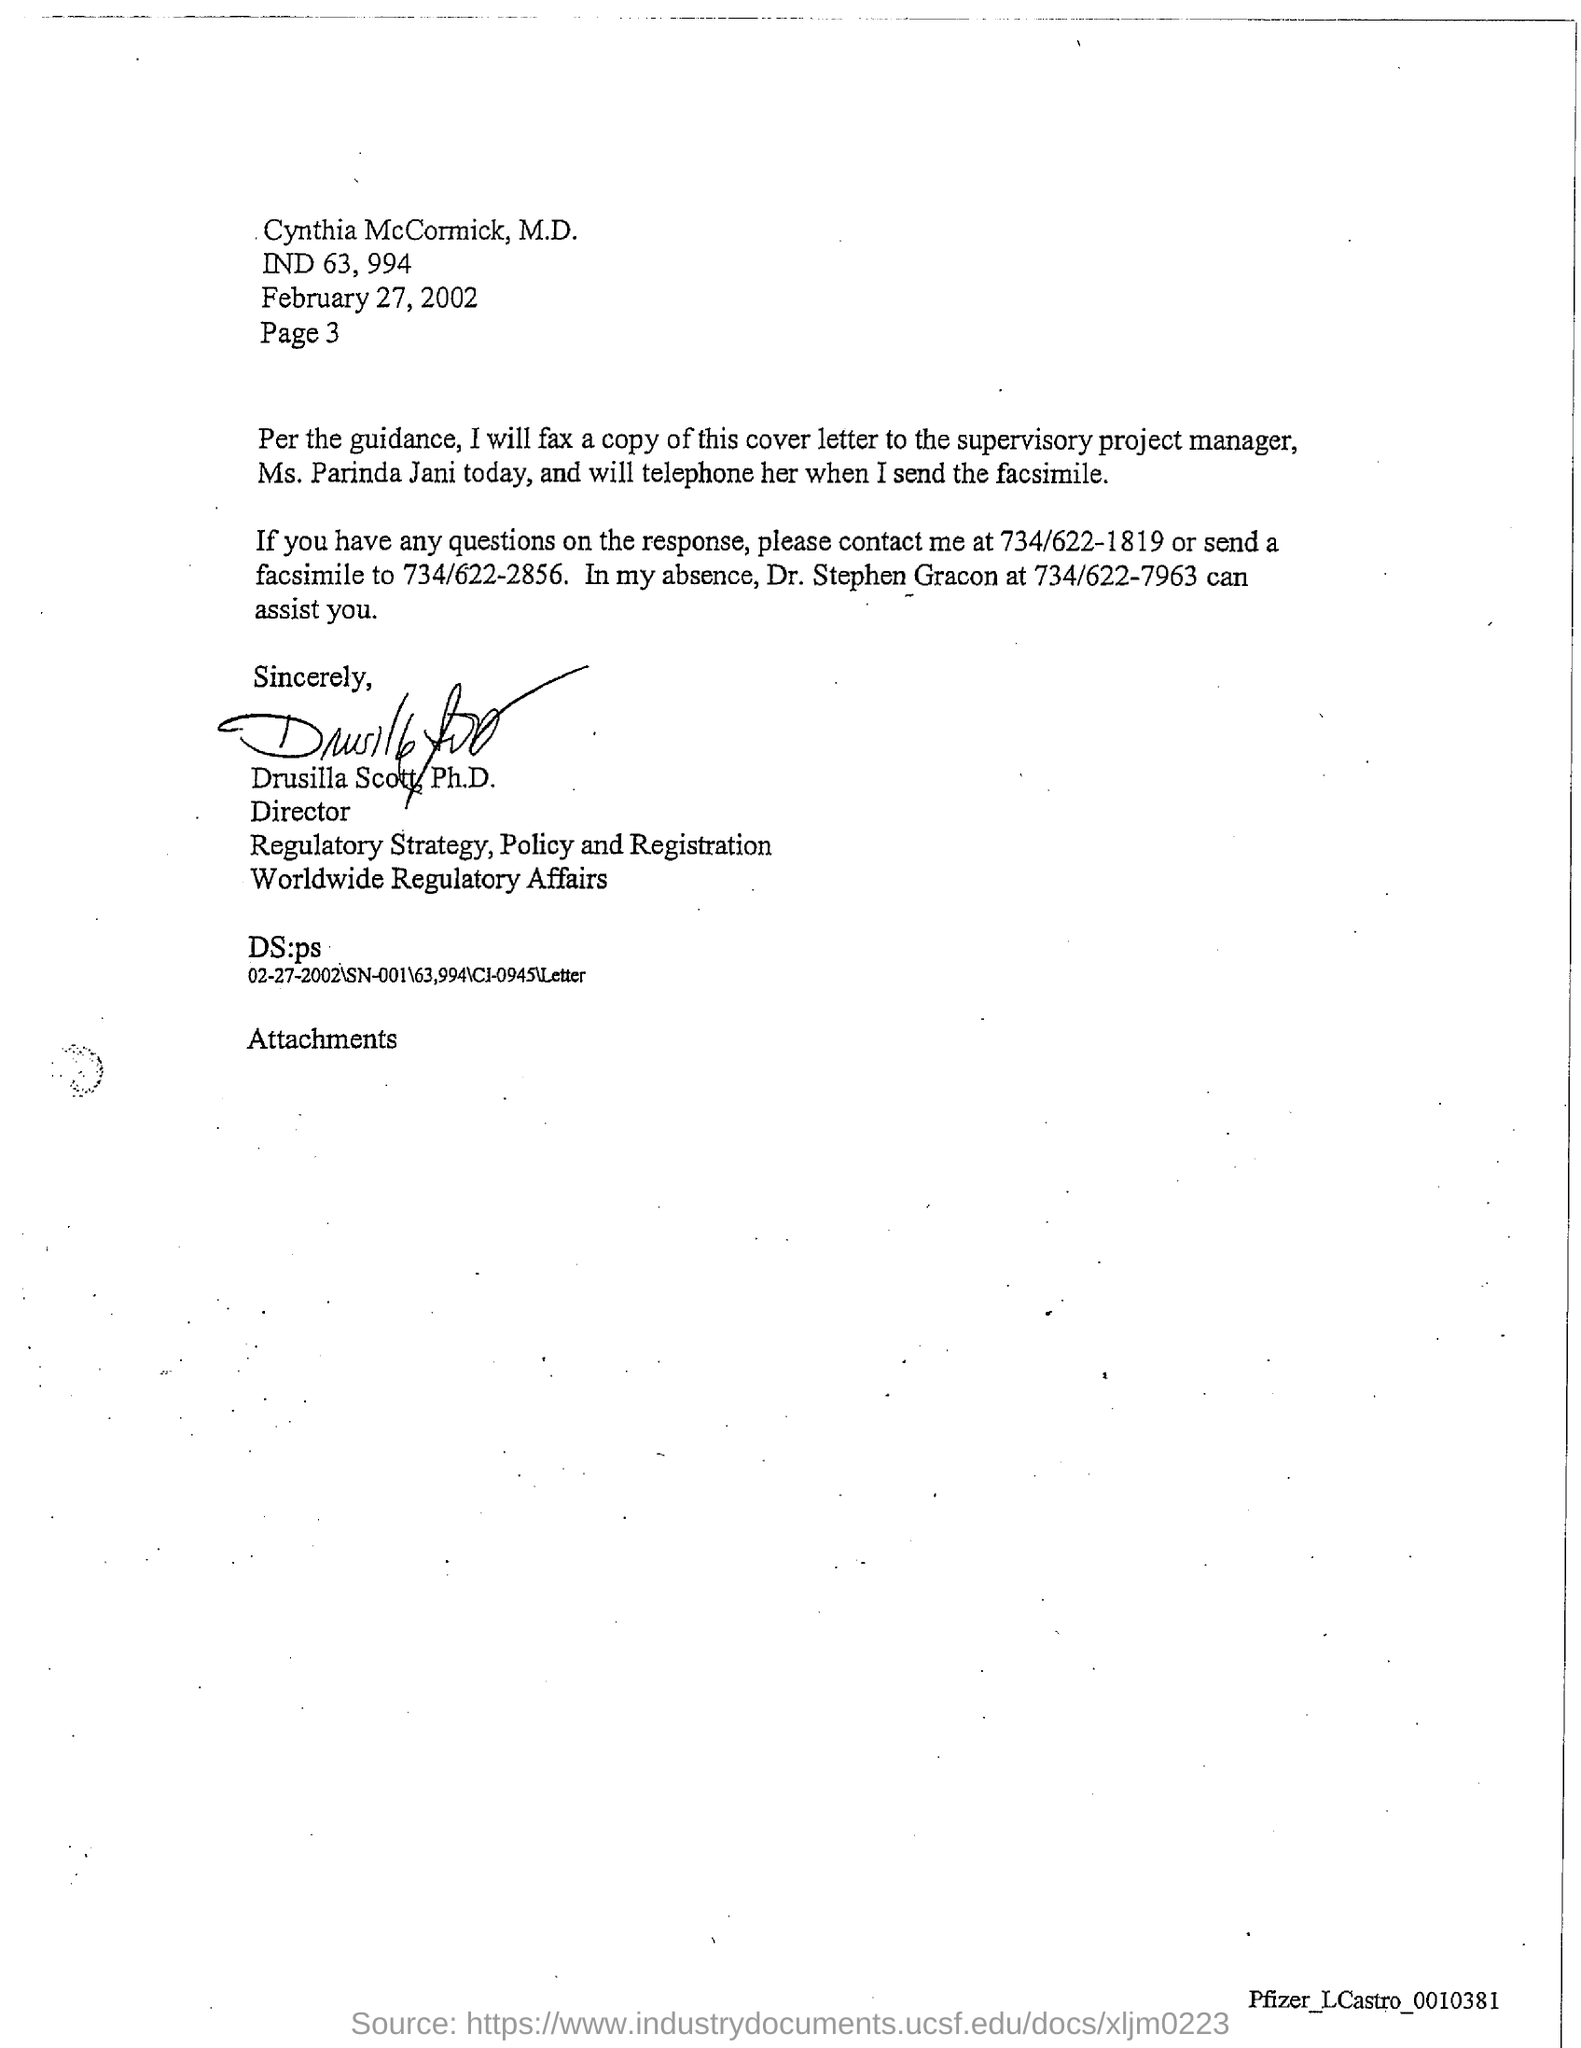Specify some key components in this picture. The letter has been signed by Drusilla Scott, Ph.D. Cynthia McCormick, M.D. is the addressee of this letter. The telephone number for Dr. Stephen Gracon mentioned in the letter is 734/622-7963. The date referred to in this letter is February 27, 2002. The page number mentioned in this letter is Page 3. 